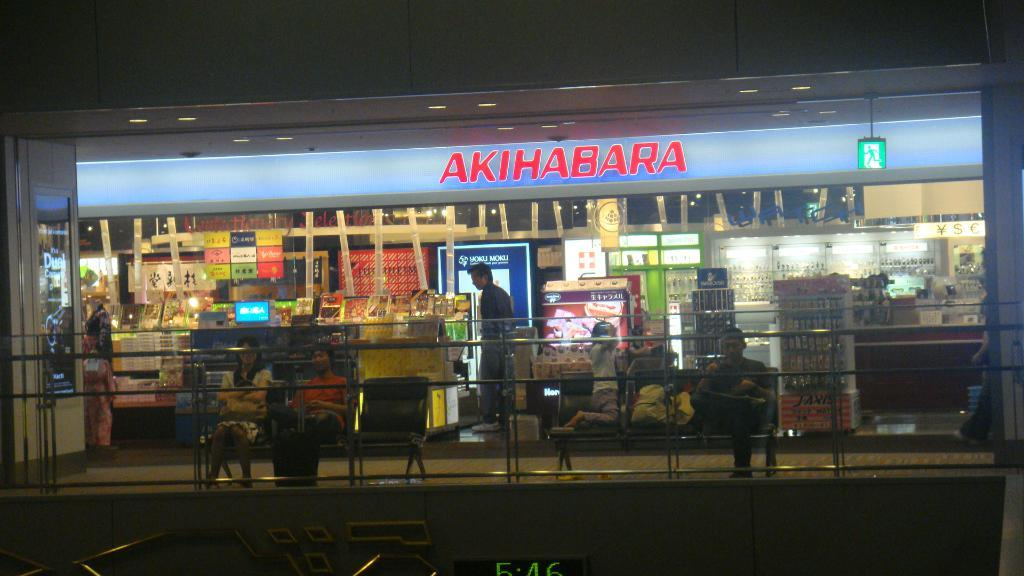Provide a one-sentence caption for the provided image. People in front of a store with the name Akihabara. 